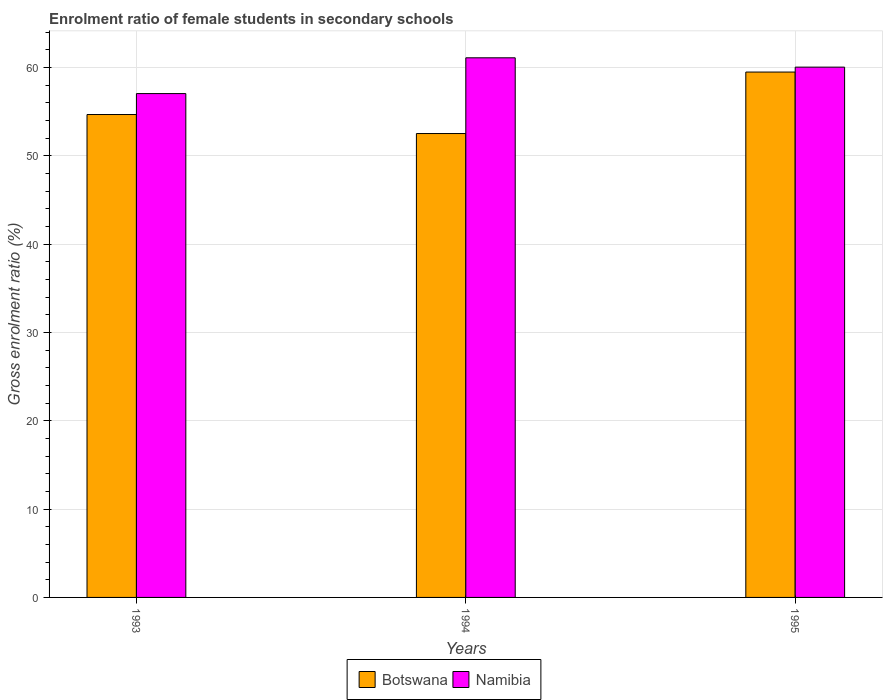How many different coloured bars are there?
Ensure brevity in your answer.  2. How many groups of bars are there?
Keep it short and to the point. 3. Are the number of bars per tick equal to the number of legend labels?
Provide a short and direct response. Yes. What is the label of the 2nd group of bars from the left?
Your answer should be very brief. 1994. What is the enrolment ratio of female students in secondary schools in Botswana in 1994?
Make the answer very short. 52.51. Across all years, what is the maximum enrolment ratio of female students in secondary schools in Namibia?
Provide a succinct answer. 61.09. Across all years, what is the minimum enrolment ratio of female students in secondary schools in Namibia?
Your response must be concise. 57.04. What is the total enrolment ratio of female students in secondary schools in Botswana in the graph?
Keep it short and to the point. 166.65. What is the difference between the enrolment ratio of female students in secondary schools in Namibia in 1993 and that in 1994?
Make the answer very short. -4.05. What is the difference between the enrolment ratio of female students in secondary schools in Namibia in 1993 and the enrolment ratio of female students in secondary schools in Botswana in 1995?
Your answer should be very brief. -2.44. What is the average enrolment ratio of female students in secondary schools in Botswana per year?
Provide a short and direct response. 55.55. In the year 1993, what is the difference between the enrolment ratio of female students in secondary schools in Namibia and enrolment ratio of female students in secondary schools in Botswana?
Your response must be concise. 2.37. In how many years, is the enrolment ratio of female students in secondary schools in Botswana greater than 62 %?
Ensure brevity in your answer.  0. What is the ratio of the enrolment ratio of female students in secondary schools in Botswana in 1994 to that in 1995?
Your answer should be very brief. 0.88. What is the difference between the highest and the second highest enrolment ratio of female students in secondary schools in Botswana?
Your answer should be compact. 4.81. What is the difference between the highest and the lowest enrolment ratio of female students in secondary schools in Namibia?
Offer a terse response. 4.05. Is the sum of the enrolment ratio of female students in secondary schools in Namibia in 1993 and 1995 greater than the maximum enrolment ratio of female students in secondary schools in Botswana across all years?
Your response must be concise. Yes. What does the 2nd bar from the left in 1995 represents?
Make the answer very short. Namibia. What does the 2nd bar from the right in 1993 represents?
Your answer should be compact. Botswana. How many bars are there?
Give a very brief answer. 6. Are all the bars in the graph horizontal?
Provide a short and direct response. No. What is the difference between two consecutive major ticks on the Y-axis?
Provide a succinct answer. 10. How many legend labels are there?
Keep it short and to the point. 2. What is the title of the graph?
Your answer should be very brief. Enrolment ratio of female students in secondary schools. Does "American Samoa" appear as one of the legend labels in the graph?
Provide a succinct answer. No. What is the label or title of the X-axis?
Ensure brevity in your answer.  Years. What is the Gross enrolment ratio (%) of Botswana in 1993?
Keep it short and to the point. 54.67. What is the Gross enrolment ratio (%) of Namibia in 1993?
Keep it short and to the point. 57.04. What is the Gross enrolment ratio (%) of Botswana in 1994?
Provide a succinct answer. 52.51. What is the Gross enrolment ratio (%) in Namibia in 1994?
Your answer should be very brief. 61.09. What is the Gross enrolment ratio (%) in Botswana in 1995?
Give a very brief answer. 59.47. What is the Gross enrolment ratio (%) of Namibia in 1995?
Ensure brevity in your answer.  60.03. Across all years, what is the maximum Gross enrolment ratio (%) of Botswana?
Your response must be concise. 59.47. Across all years, what is the maximum Gross enrolment ratio (%) of Namibia?
Your answer should be very brief. 61.09. Across all years, what is the minimum Gross enrolment ratio (%) of Botswana?
Provide a succinct answer. 52.51. Across all years, what is the minimum Gross enrolment ratio (%) of Namibia?
Ensure brevity in your answer.  57.04. What is the total Gross enrolment ratio (%) of Botswana in the graph?
Your answer should be compact. 166.65. What is the total Gross enrolment ratio (%) of Namibia in the graph?
Your answer should be very brief. 178.15. What is the difference between the Gross enrolment ratio (%) of Botswana in 1993 and that in 1994?
Your response must be concise. 2.15. What is the difference between the Gross enrolment ratio (%) of Namibia in 1993 and that in 1994?
Make the answer very short. -4.05. What is the difference between the Gross enrolment ratio (%) in Botswana in 1993 and that in 1995?
Your response must be concise. -4.81. What is the difference between the Gross enrolment ratio (%) of Namibia in 1993 and that in 1995?
Provide a short and direct response. -2.99. What is the difference between the Gross enrolment ratio (%) of Botswana in 1994 and that in 1995?
Ensure brevity in your answer.  -6.96. What is the difference between the Gross enrolment ratio (%) of Namibia in 1994 and that in 1995?
Provide a short and direct response. 1.06. What is the difference between the Gross enrolment ratio (%) of Botswana in 1993 and the Gross enrolment ratio (%) of Namibia in 1994?
Keep it short and to the point. -6.42. What is the difference between the Gross enrolment ratio (%) in Botswana in 1993 and the Gross enrolment ratio (%) in Namibia in 1995?
Your answer should be compact. -5.36. What is the difference between the Gross enrolment ratio (%) in Botswana in 1994 and the Gross enrolment ratio (%) in Namibia in 1995?
Provide a succinct answer. -7.52. What is the average Gross enrolment ratio (%) of Botswana per year?
Provide a succinct answer. 55.55. What is the average Gross enrolment ratio (%) of Namibia per year?
Keep it short and to the point. 59.38. In the year 1993, what is the difference between the Gross enrolment ratio (%) of Botswana and Gross enrolment ratio (%) of Namibia?
Your answer should be very brief. -2.37. In the year 1994, what is the difference between the Gross enrolment ratio (%) of Botswana and Gross enrolment ratio (%) of Namibia?
Your answer should be compact. -8.57. In the year 1995, what is the difference between the Gross enrolment ratio (%) of Botswana and Gross enrolment ratio (%) of Namibia?
Keep it short and to the point. -0.56. What is the ratio of the Gross enrolment ratio (%) of Botswana in 1993 to that in 1994?
Your answer should be compact. 1.04. What is the ratio of the Gross enrolment ratio (%) in Namibia in 1993 to that in 1994?
Keep it short and to the point. 0.93. What is the ratio of the Gross enrolment ratio (%) of Botswana in 1993 to that in 1995?
Ensure brevity in your answer.  0.92. What is the ratio of the Gross enrolment ratio (%) in Namibia in 1993 to that in 1995?
Make the answer very short. 0.95. What is the ratio of the Gross enrolment ratio (%) in Botswana in 1994 to that in 1995?
Provide a short and direct response. 0.88. What is the ratio of the Gross enrolment ratio (%) of Namibia in 1994 to that in 1995?
Your answer should be very brief. 1.02. What is the difference between the highest and the second highest Gross enrolment ratio (%) of Botswana?
Ensure brevity in your answer.  4.81. What is the difference between the highest and the second highest Gross enrolment ratio (%) of Namibia?
Your answer should be compact. 1.06. What is the difference between the highest and the lowest Gross enrolment ratio (%) in Botswana?
Offer a terse response. 6.96. What is the difference between the highest and the lowest Gross enrolment ratio (%) of Namibia?
Offer a terse response. 4.05. 